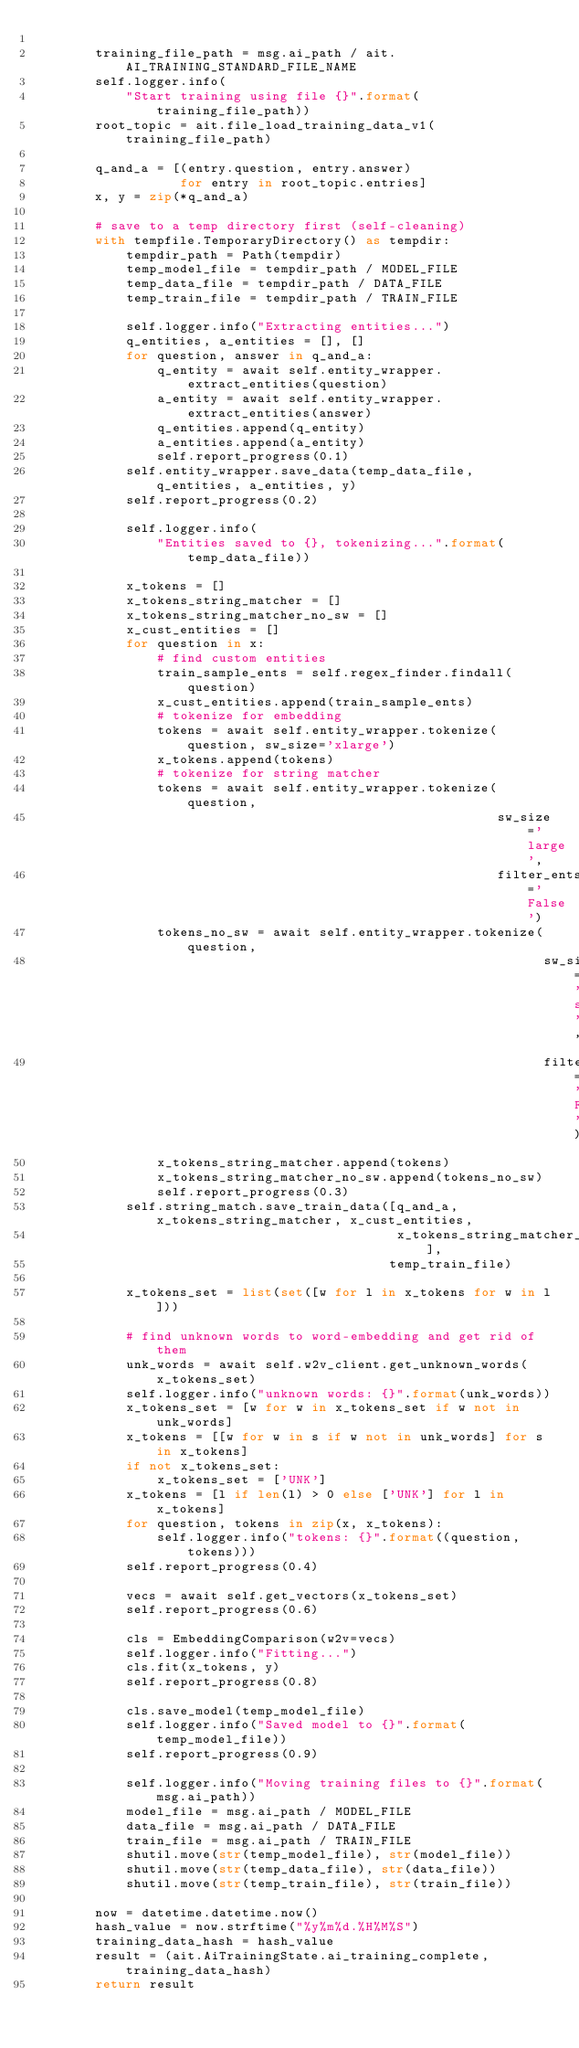<code> <loc_0><loc_0><loc_500><loc_500><_Python_>
        training_file_path = msg.ai_path / ait.AI_TRAINING_STANDARD_FILE_NAME
        self.logger.info(
            "Start training using file {}".format(training_file_path))
        root_topic = ait.file_load_training_data_v1(training_file_path)

        q_and_a = [(entry.question, entry.answer)
                   for entry in root_topic.entries]
        x, y = zip(*q_and_a)

        # save to a temp directory first (self-cleaning)
        with tempfile.TemporaryDirectory() as tempdir:
            tempdir_path = Path(tempdir)
            temp_model_file = tempdir_path / MODEL_FILE
            temp_data_file = tempdir_path / DATA_FILE
            temp_train_file = tempdir_path / TRAIN_FILE

            self.logger.info("Extracting entities...")
            q_entities, a_entities = [], []
            for question, answer in q_and_a:
                q_entity = await self.entity_wrapper.extract_entities(question)
                a_entity = await self.entity_wrapper.extract_entities(answer)
                q_entities.append(q_entity)
                a_entities.append(a_entity)
                self.report_progress(0.1)
            self.entity_wrapper.save_data(temp_data_file, q_entities, a_entities, y)
            self.report_progress(0.2)

            self.logger.info(
                "Entities saved to {}, tokenizing...".format(temp_data_file))

            x_tokens = []
            x_tokens_string_matcher = []
            x_tokens_string_matcher_no_sw = []
            x_cust_entities = []
            for question in x:
                # find custom entities
                train_sample_ents = self.regex_finder.findall(question)
                x_cust_entities.append(train_sample_ents)
                # tokenize for embedding
                tokens = await self.entity_wrapper.tokenize(question, sw_size='xlarge')
                x_tokens.append(tokens)
                # tokenize for string matcher
                tokens = await self.entity_wrapper.tokenize(question,
                                                            sw_size='large',
                                                            filter_ents='False')
                tokens_no_sw = await self.entity_wrapper.tokenize(question,
                                                                  sw_size='small',
                                                                  filter_ents='False')
                x_tokens_string_matcher.append(tokens)
                x_tokens_string_matcher_no_sw.append(tokens_no_sw)
                self.report_progress(0.3)
            self.string_match.save_train_data([q_and_a, x_tokens_string_matcher, x_cust_entities,
                                               x_tokens_string_matcher_no_sw],
                                              temp_train_file)

            x_tokens_set = list(set([w for l in x_tokens for w in l]))

            # find unknown words to word-embedding and get rid of them
            unk_words = await self.w2v_client.get_unknown_words(x_tokens_set)
            self.logger.info("unknown words: {}".format(unk_words))
            x_tokens_set = [w for w in x_tokens_set if w not in unk_words]
            x_tokens = [[w for w in s if w not in unk_words] for s in x_tokens]
            if not x_tokens_set:
                x_tokens_set = ['UNK']
            x_tokens = [l if len(l) > 0 else ['UNK'] for l in x_tokens]
            for question, tokens in zip(x, x_tokens):
                self.logger.info("tokens: {}".format((question, tokens)))
            self.report_progress(0.4)

            vecs = await self.get_vectors(x_tokens_set)
            self.report_progress(0.6)

            cls = EmbeddingComparison(w2v=vecs)
            self.logger.info("Fitting...")
            cls.fit(x_tokens, y)
            self.report_progress(0.8)

            cls.save_model(temp_model_file)
            self.logger.info("Saved model to {}".format(temp_model_file))
            self.report_progress(0.9)

            self.logger.info("Moving training files to {}".format(msg.ai_path))
            model_file = msg.ai_path / MODEL_FILE
            data_file = msg.ai_path / DATA_FILE
            train_file = msg.ai_path / TRAIN_FILE
            shutil.move(str(temp_model_file), str(model_file))
            shutil.move(str(temp_data_file), str(data_file))
            shutil.move(str(temp_train_file), str(train_file))

        now = datetime.datetime.now()
        hash_value = now.strftime("%y%m%d.%H%M%S")
        training_data_hash = hash_value
        result = (ait.AiTrainingState.ai_training_complete, training_data_hash)
        return result
</code> 